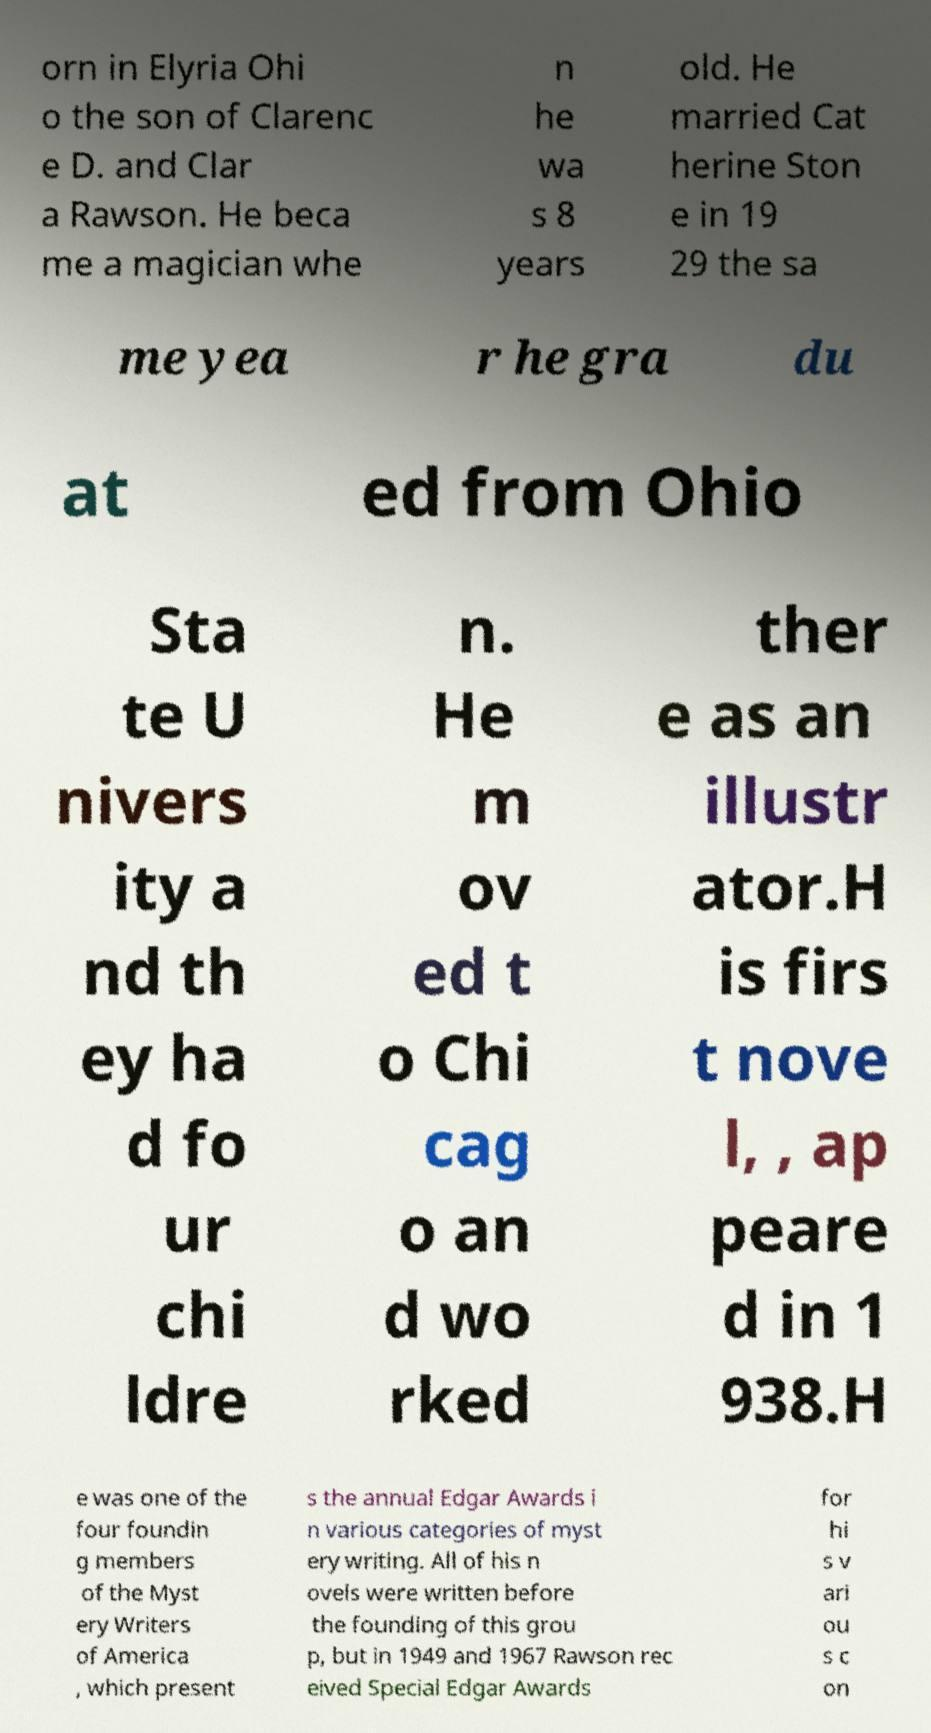There's text embedded in this image that I need extracted. Can you transcribe it verbatim? orn in Elyria Ohi o the son of Clarenc e D. and Clar a Rawson. He beca me a magician whe n he wa s 8 years old. He married Cat herine Ston e in 19 29 the sa me yea r he gra du at ed from Ohio Sta te U nivers ity a nd th ey ha d fo ur chi ldre n. He m ov ed t o Chi cag o an d wo rked ther e as an illustr ator.H is firs t nove l, , ap peare d in 1 938.H e was one of the four foundin g members of the Myst ery Writers of America , which present s the annual Edgar Awards i n various categories of myst ery writing. All of his n ovels were written before the founding of this grou p, but in 1949 and 1967 Rawson rec eived Special Edgar Awards for hi s v ari ou s c on 